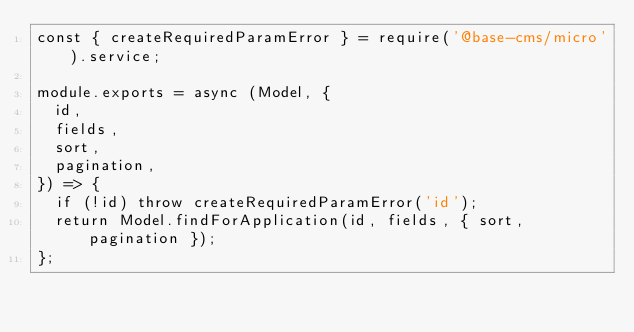<code> <loc_0><loc_0><loc_500><loc_500><_JavaScript_>const { createRequiredParamError } = require('@base-cms/micro').service;

module.exports = async (Model, {
  id,
  fields,
  sort,
  pagination,
}) => {
  if (!id) throw createRequiredParamError('id');
  return Model.findForApplication(id, fields, { sort, pagination });
};
</code> 